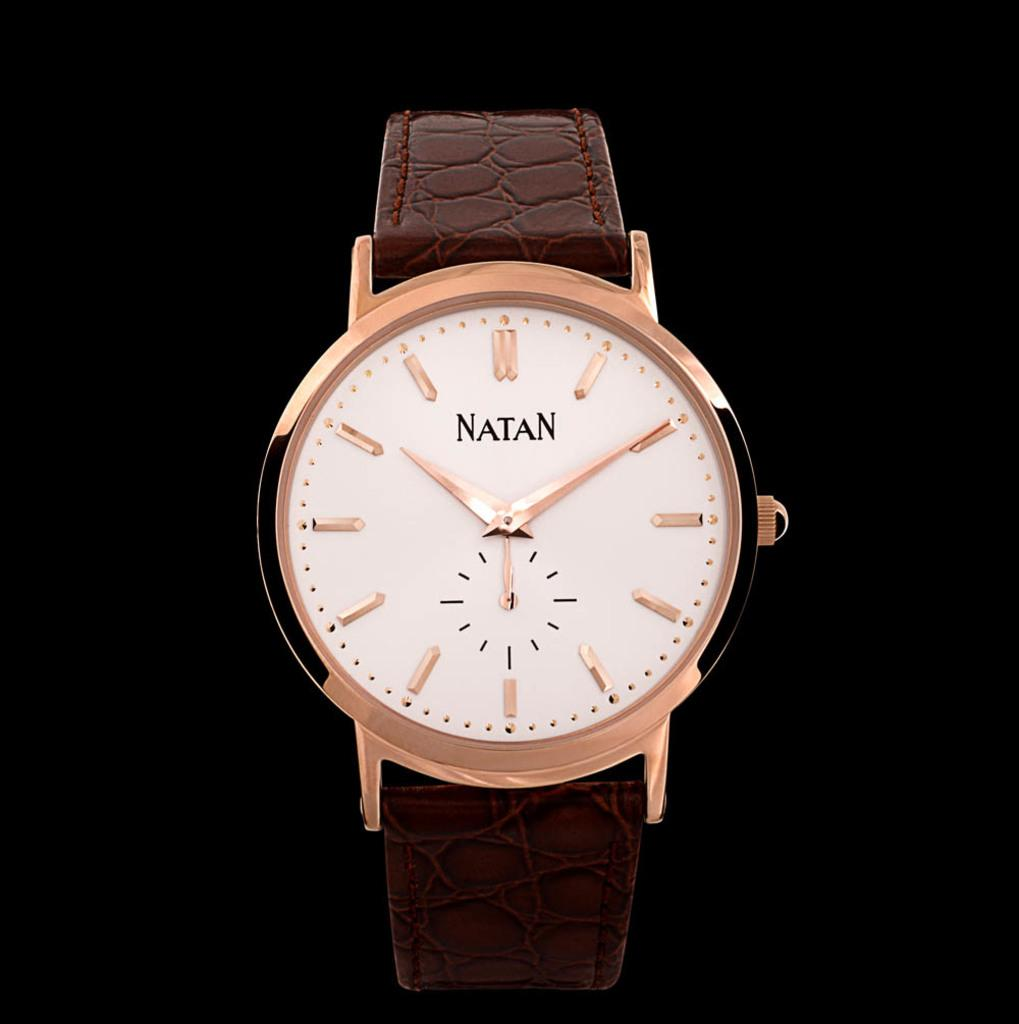<image>
Give a short and clear explanation of the subsequent image. A gold Natan watch has a textured leather band 